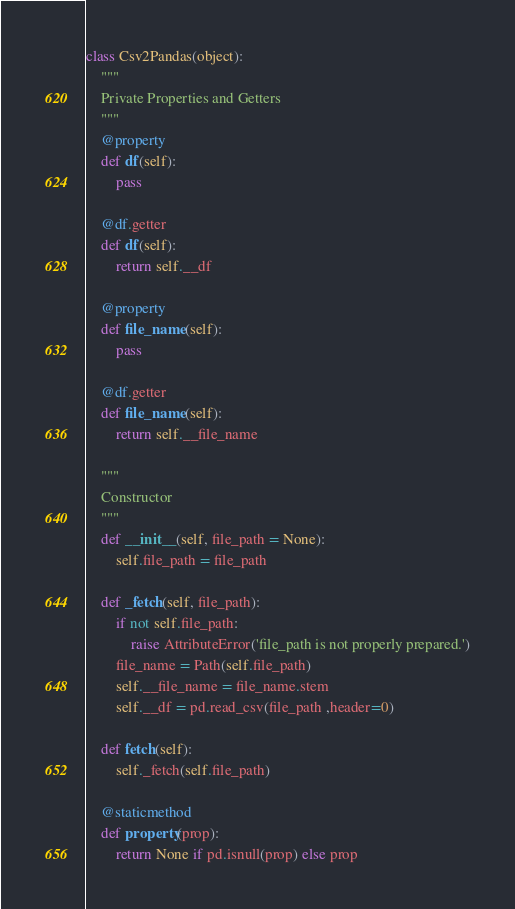<code> <loc_0><loc_0><loc_500><loc_500><_Python_>class Csv2Pandas(object):
    """
    Private Properties and Getters
    """
    @property
    def df(self):
        pass

    @df.getter
    def df(self):
        return self.__df

    @property
    def file_name(self):
        pass

    @df.getter
    def file_name(self):
        return self.__file_name

    """
    Constructor
    """
    def __init__(self, file_path = None):
        self.file_path = file_path

    def _fetch(self, file_path):
        if not self.file_path:
            raise AttributeError('file_path is not properly prepared.')
        file_name = Path(self.file_path)
        self.__file_name = file_name.stem
        self.__df = pd.read_csv(file_path ,header=0)

    def fetch(self):
        self._fetch(self.file_path)

    @staticmethod
    def property(prop):
        return None if pd.isnull(prop) else prop
</code> 